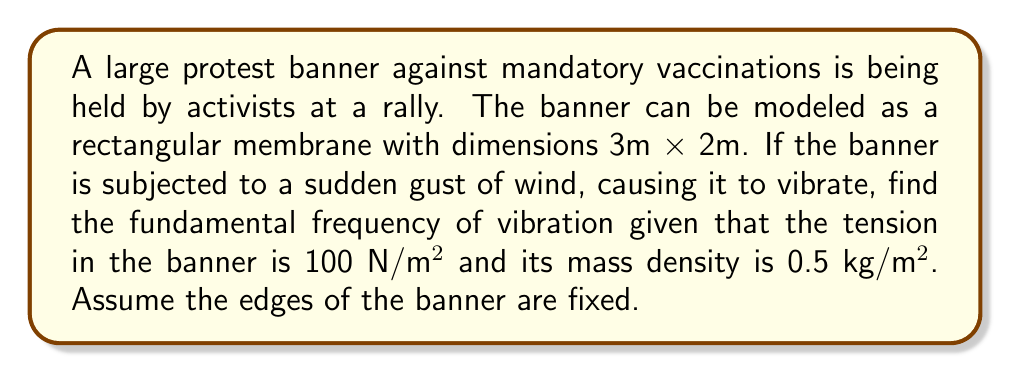Teach me how to tackle this problem. To solve this problem, we'll use the wave equation for a rectangular membrane:

1) The wave equation for a 2D membrane is:
   $$\frac{\partial^2 u}{\partial t^2} = c^2 \left(\frac{\partial^2 u}{\partial x^2} + \frac{\partial^2 u}{\partial y^2}\right)$$

2) The general solution for a rectangular membrane with fixed edges is:
   $$u(x,y,t) = \sum_{m=1}^{\infty}\sum_{n=1}^{\infty} A_{mn} \sin(\frac{m\pi x}{L_x}) \sin(\frac{n\pi y}{L_y}) \cos(\omega_{mn}t + \phi_{mn})$$

3) The frequencies are given by:
   $$\omega_{mn} = \pi c \sqrt{\left(\frac{m}{L_x}\right)^2 + \left(\frac{n}{L_y}\right)^2}$$

4) The fundamental frequency is when m = n = 1:
   $$\omega_{11} = \pi c \sqrt{\left(\frac{1}{L_x}\right)^2 + \left(\frac{1}{L_y}\right)^2}$$

5) The wave speed c is given by:
   $$c = \sqrt{\frac{T}{\rho}}$$
   where T is tension per unit length and ρ is mass density.

6) Calculate c:
   $$c = \sqrt{\frac{100 \text{ N/m²}}{0.5 \text{ kg/m²}}} = 14.14 \text{ m/s}$$

7) Now, calculate the fundamental frequency:
   $$\omega_{11} = \pi (14.14) \sqrt{\left(\frac{1}{3}\right)^2 + \left(\frac{1}{2}\right)^2}$$
   $$= 44.44 \sqrt{0.1111 + 0.25} = 44.44 \sqrt{0.3611} = 26.70 \text{ rad/s}$$

8) Convert to Hz:
   $$f = \frac{\omega}{2\pi} = \frac{26.70}{2\pi} = 4.25 \text{ Hz}$$
Answer: 4.25 Hz 